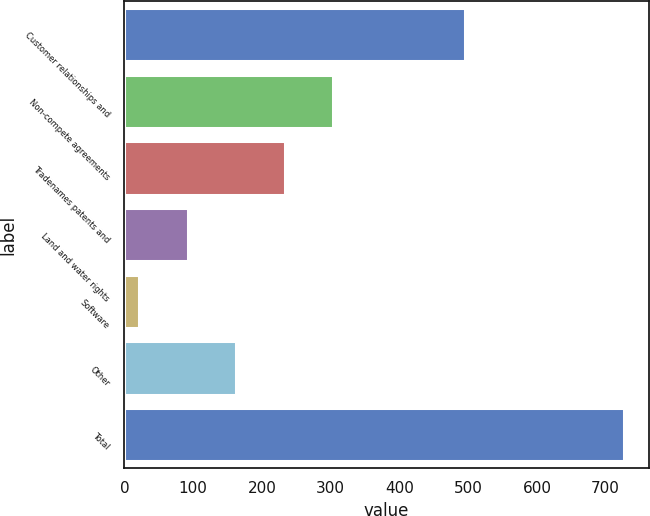Convert chart to OTSL. <chart><loc_0><loc_0><loc_500><loc_500><bar_chart><fcel>Customer relationships and<fcel>Non-compete agreements<fcel>Tradenames patents and<fcel>Land and water rights<fcel>Software<fcel>Other<fcel>Total<nl><fcel>495<fcel>303.6<fcel>233.2<fcel>92.4<fcel>22<fcel>162.8<fcel>726<nl></chart> 